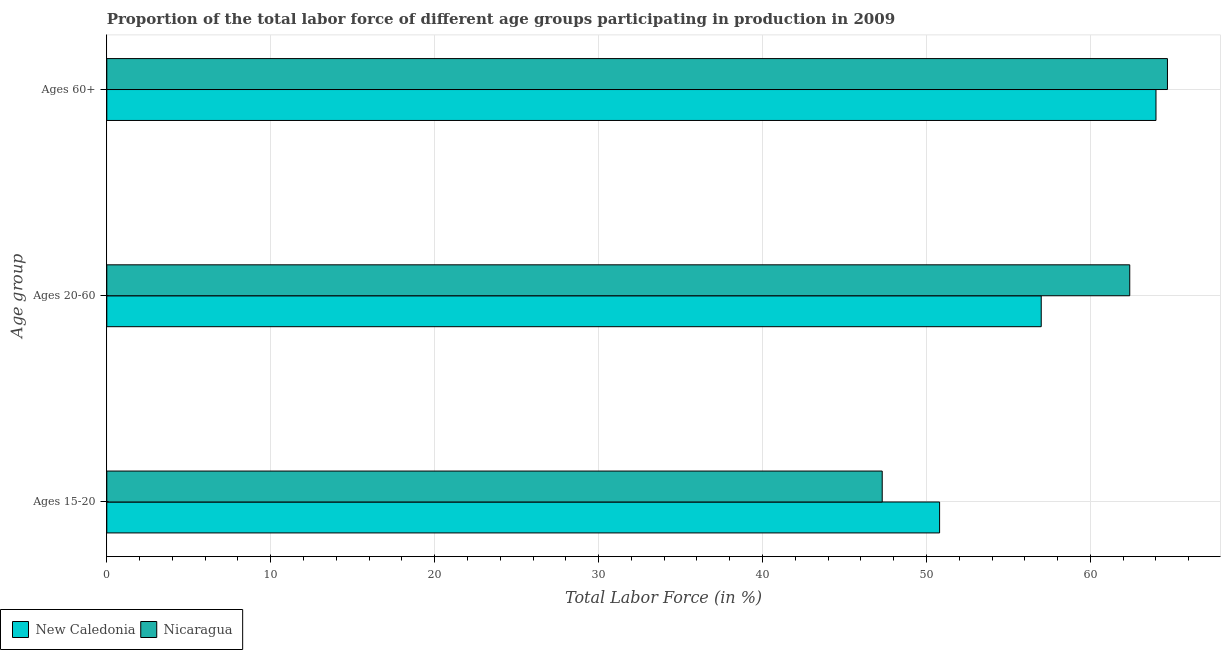How many groups of bars are there?
Offer a terse response. 3. Are the number of bars per tick equal to the number of legend labels?
Ensure brevity in your answer.  Yes. Are the number of bars on each tick of the Y-axis equal?
Offer a terse response. Yes. How many bars are there on the 2nd tick from the bottom?
Offer a terse response. 2. What is the label of the 3rd group of bars from the top?
Offer a very short reply. Ages 15-20. What is the percentage of labor force within the age group 15-20 in New Caledonia?
Provide a short and direct response. 50.8. Across all countries, what is the maximum percentage of labor force within the age group 15-20?
Provide a succinct answer. 50.8. Across all countries, what is the minimum percentage of labor force above age 60?
Make the answer very short. 64. In which country was the percentage of labor force within the age group 20-60 maximum?
Your answer should be compact. Nicaragua. In which country was the percentage of labor force within the age group 15-20 minimum?
Ensure brevity in your answer.  Nicaragua. What is the total percentage of labor force within the age group 20-60 in the graph?
Provide a short and direct response. 119.4. What is the difference between the percentage of labor force within the age group 20-60 in Nicaragua and that in New Caledonia?
Your response must be concise. 5.4. What is the difference between the percentage of labor force within the age group 15-20 in New Caledonia and the percentage of labor force within the age group 20-60 in Nicaragua?
Provide a succinct answer. -11.6. What is the average percentage of labor force within the age group 20-60 per country?
Your answer should be very brief. 59.7. What is the difference between the percentage of labor force within the age group 20-60 and percentage of labor force within the age group 15-20 in New Caledonia?
Provide a succinct answer. 6.2. What is the ratio of the percentage of labor force above age 60 in Nicaragua to that in New Caledonia?
Your response must be concise. 1.01. Is the difference between the percentage of labor force within the age group 20-60 in New Caledonia and Nicaragua greater than the difference between the percentage of labor force within the age group 15-20 in New Caledonia and Nicaragua?
Your response must be concise. No. What is the difference between the highest and the second highest percentage of labor force within the age group 20-60?
Offer a terse response. 5.4. What is the difference between the highest and the lowest percentage of labor force above age 60?
Give a very brief answer. 0.7. In how many countries, is the percentage of labor force within the age group 20-60 greater than the average percentage of labor force within the age group 20-60 taken over all countries?
Give a very brief answer. 1. Is the sum of the percentage of labor force within the age group 15-20 in New Caledonia and Nicaragua greater than the maximum percentage of labor force above age 60 across all countries?
Your answer should be compact. Yes. What does the 1st bar from the top in Ages 60+ represents?
Your response must be concise. Nicaragua. What does the 1st bar from the bottom in Ages 15-20 represents?
Your answer should be compact. New Caledonia. How many bars are there?
Make the answer very short. 6. What is the difference between two consecutive major ticks on the X-axis?
Ensure brevity in your answer.  10. Are the values on the major ticks of X-axis written in scientific E-notation?
Provide a succinct answer. No. How many legend labels are there?
Offer a very short reply. 2. What is the title of the graph?
Offer a very short reply. Proportion of the total labor force of different age groups participating in production in 2009. Does "Faeroe Islands" appear as one of the legend labels in the graph?
Ensure brevity in your answer.  No. What is the label or title of the X-axis?
Your response must be concise. Total Labor Force (in %). What is the label or title of the Y-axis?
Give a very brief answer. Age group. What is the Total Labor Force (in %) in New Caledonia in Ages 15-20?
Offer a very short reply. 50.8. What is the Total Labor Force (in %) of Nicaragua in Ages 15-20?
Your response must be concise. 47.3. What is the Total Labor Force (in %) in New Caledonia in Ages 20-60?
Give a very brief answer. 57. What is the Total Labor Force (in %) of Nicaragua in Ages 20-60?
Your answer should be compact. 62.4. What is the Total Labor Force (in %) of New Caledonia in Ages 60+?
Your answer should be compact. 64. What is the Total Labor Force (in %) of Nicaragua in Ages 60+?
Give a very brief answer. 64.7. Across all Age group, what is the maximum Total Labor Force (in %) of Nicaragua?
Your response must be concise. 64.7. Across all Age group, what is the minimum Total Labor Force (in %) in New Caledonia?
Offer a very short reply. 50.8. Across all Age group, what is the minimum Total Labor Force (in %) in Nicaragua?
Make the answer very short. 47.3. What is the total Total Labor Force (in %) of New Caledonia in the graph?
Ensure brevity in your answer.  171.8. What is the total Total Labor Force (in %) in Nicaragua in the graph?
Provide a short and direct response. 174.4. What is the difference between the Total Labor Force (in %) of New Caledonia in Ages 15-20 and that in Ages 20-60?
Your answer should be compact. -6.2. What is the difference between the Total Labor Force (in %) in Nicaragua in Ages 15-20 and that in Ages 20-60?
Your answer should be very brief. -15.1. What is the difference between the Total Labor Force (in %) in New Caledonia in Ages 15-20 and that in Ages 60+?
Provide a short and direct response. -13.2. What is the difference between the Total Labor Force (in %) of Nicaragua in Ages 15-20 and that in Ages 60+?
Provide a succinct answer. -17.4. What is the difference between the Total Labor Force (in %) of New Caledonia in Ages 15-20 and the Total Labor Force (in %) of Nicaragua in Ages 60+?
Provide a short and direct response. -13.9. What is the difference between the Total Labor Force (in %) in New Caledonia in Ages 20-60 and the Total Labor Force (in %) in Nicaragua in Ages 60+?
Your answer should be very brief. -7.7. What is the average Total Labor Force (in %) in New Caledonia per Age group?
Your answer should be compact. 57.27. What is the average Total Labor Force (in %) in Nicaragua per Age group?
Ensure brevity in your answer.  58.13. What is the difference between the Total Labor Force (in %) in New Caledonia and Total Labor Force (in %) in Nicaragua in Ages 15-20?
Provide a short and direct response. 3.5. What is the ratio of the Total Labor Force (in %) of New Caledonia in Ages 15-20 to that in Ages 20-60?
Provide a short and direct response. 0.89. What is the ratio of the Total Labor Force (in %) in Nicaragua in Ages 15-20 to that in Ages 20-60?
Provide a succinct answer. 0.76. What is the ratio of the Total Labor Force (in %) in New Caledonia in Ages 15-20 to that in Ages 60+?
Provide a short and direct response. 0.79. What is the ratio of the Total Labor Force (in %) of Nicaragua in Ages 15-20 to that in Ages 60+?
Your answer should be compact. 0.73. What is the ratio of the Total Labor Force (in %) in New Caledonia in Ages 20-60 to that in Ages 60+?
Give a very brief answer. 0.89. What is the ratio of the Total Labor Force (in %) in Nicaragua in Ages 20-60 to that in Ages 60+?
Ensure brevity in your answer.  0.96. What is the difference between the highest and the second highest Total Labor Force (in %) in Nicaragua?
Give a very brief answer. 2.3. What is the difference between the highest and the lowest Total Labor Force (in %) in New Caledonia?
Give a very brief answer. 13.2. What is the difference between the highest and the lowest Total Labor Force (in %) of Nicaragua?
Offer a terse response. 17.4. 